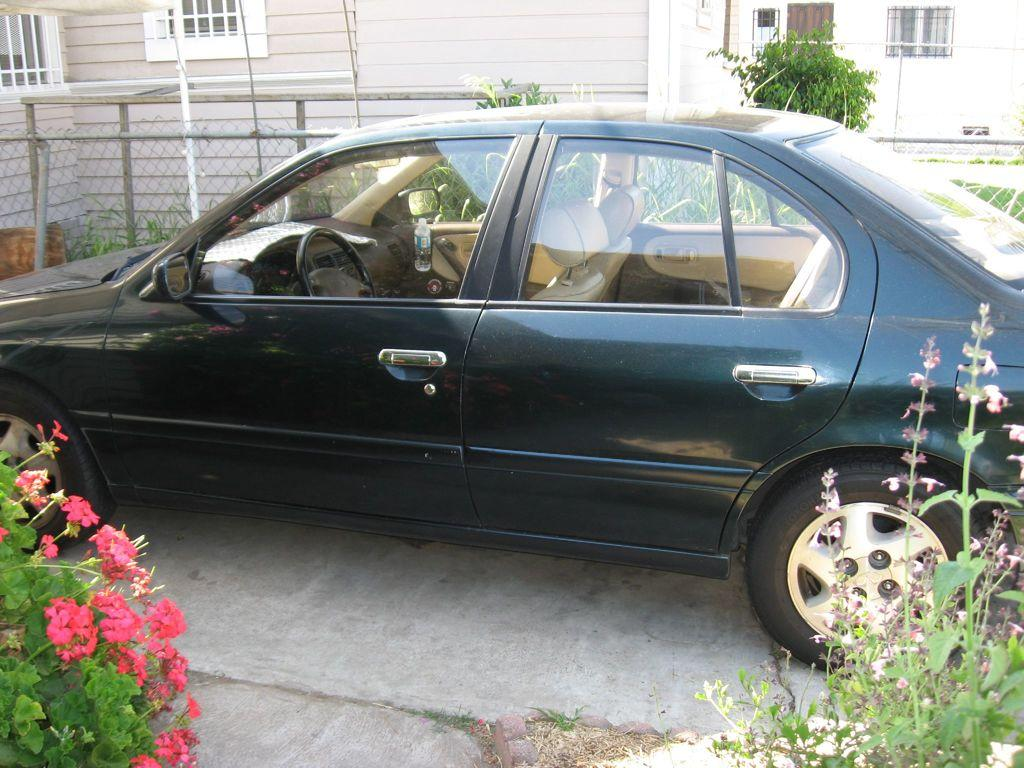What is the main subject of the picture? The main subject of the picture is a car. Where is the car located in relation to the house? The car is parked near a house. What is the color of the car? The car is black in color. What type of vegetation can be seen in the picture? There are plants and flowers in the picture. Can you tell me how many kettles are visible in the picture? There are no kettles present in the picture; it features a car parked near a house with plants and flowers. 